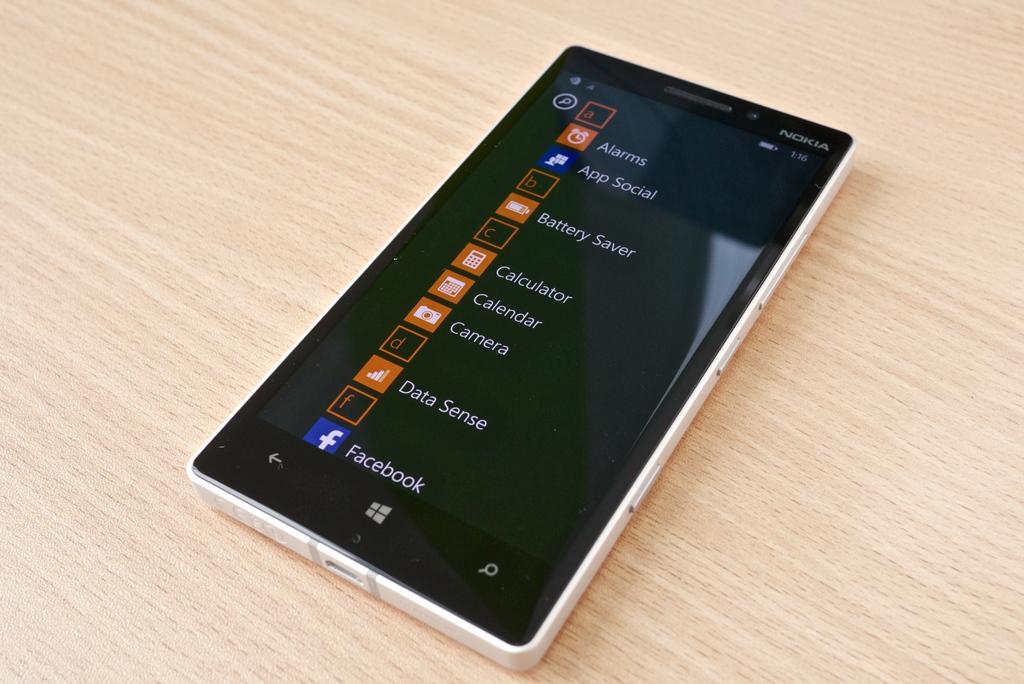What brand is this phone?
Provide a short and direct response. Nokia. 